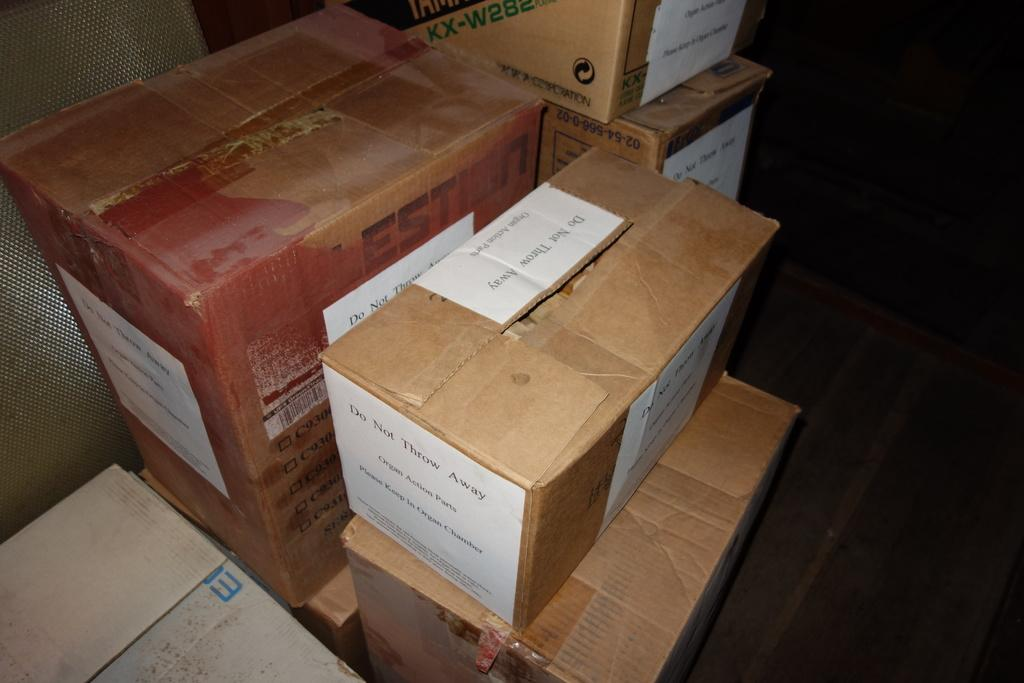<image>
Describe the image concisely. A group of cardboard boxes and packages with the words Do Not Throw Away on its side. 